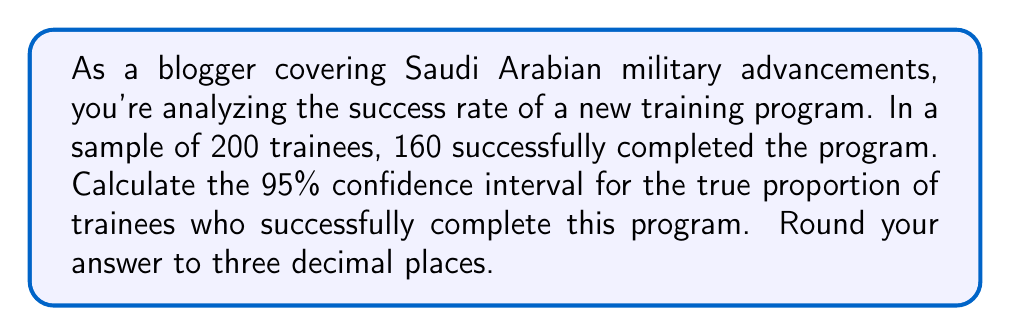Can you answer this question? Let's approach this step-by-step:

1) We're dealing with a proportion, so we'll use the formula for the confidence interval of a proportion:

   $$\hat{p} \pm z^* \sqrt{\frac{\hat{p}(1-\hat{p})}{n}}$$

   Where:
   $\hat{p}$ is the sample proportion
   $z^*$ is the critical value for the desired confidence level
   $n$ is the sample size

2) Calculate $\hat{p}$:
   $$\hat{p} = \frac{160}{200} = 0.8$$

3) For a 95% confidence interval, $z^* = 1.96$

4) Now, let's plug these values into our formula:

   $$0.8 \pm 1.96 \sqrt{\frac{0.8(1-0.8)}{200}}$$

5) Simplify inside the square root:
   $$0.8 \pm 1.96 \sqrt{\frac{0.8(0.2)}{200}} = 0.8 \pm 1.96 \sqrt{\frac{0.16}{200}} = 0.8 \pm 1.96 \sqrt{0.0008}$$

6) Calculate:
   $$0.8 \pm 1.96(0.0283) = 0.8 \pm 0.0555$$

7) Therefore, the confidence interval is:
   $$(0.8 - 0.0555, 0.8 + 0.0555) = (0.7445, 0.8555)$$

8) Rounding to three decimal places:
   $$(0.745, 0.856)$$
Answer: (0.745, 0.856) 